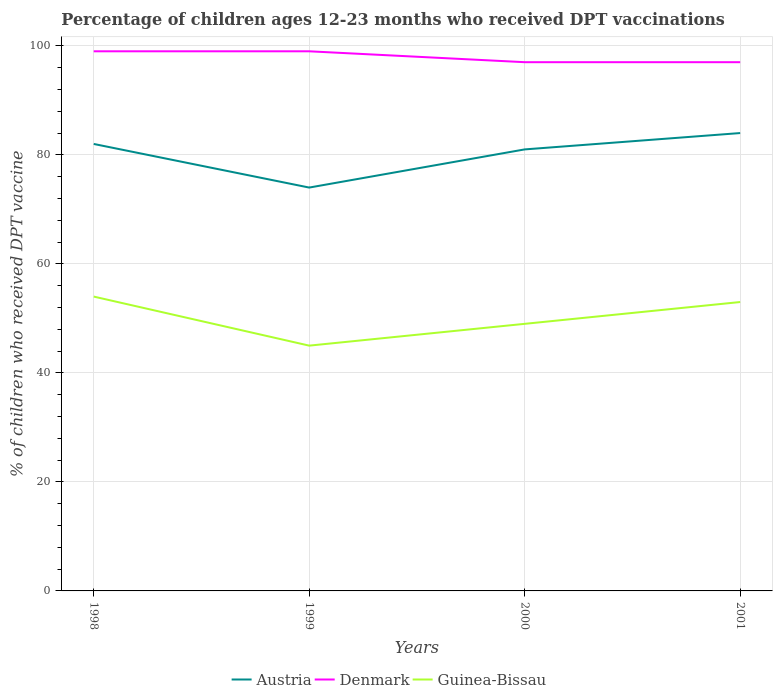Does the line corresponding to Guinea-Bissau intersect with the line corresponding to Austria?
Ensure brevity in your answer.  No. Across all years, what is the maximum percentage of children who received DPT vaccination in Austria?
Offer a very short reply. 74. In which year was the percentage of children who received DPT vaccination in Denmark maximum?
Your response must be concise. 2000. What is the difference between the highest and the second highest percentage of children who received DPT vaccination in Austria?
Provide a succinct answer. 10. What is the difference between the highest and the lowest percentage of children who received DPT vaccination in Guinea-Bissau?
Offer a very short reply. 2. Is the percentage of children who received DPT vaccination in Denmark strictly greater than the percentage of children who received DPT vaccination in Austria over the years?
Your response must be concise. No. Are the values on the major ticks of Y-axis written in scientific E-notation?
Provide a succinct answer. No. Where does the legend appear in the graph?
Offer a terse response. Bottom center. What is the title of the graph?
Keep it short and to the point. Percentage of children ages 12-23 months who received DPT vaccinations. What is the label or title of the X-axis?
Ensure brevity in your answer.  Years. What is the label or title of the Y-axis?
Your answer should be very brief. % of children who received DPT vaccine. What is the % of children who received DPT vaccine in Austria in 1998?
Your answer should be very brief. 82. What is the % of children who received DPT vaccine in Austria in 1999?
Make the answer very short. 74. What is the % of children who received DPT vaccine of Guinea-Bissau in 1999?
Offer a terse response. 45. What is the % of children who received DPT vaccine of Austria in 2000?
Your answer should be compact. 81. What is the % of children who received DPT vaccine in Denmark in 2000?
Provide a succinct answer. 97. What is the % of children who received DPT vaccine of Guinea-Bissau in 2000?
Offer a terse response. 49. What is the % of children who received DPT vaccine in Denmark in 2001?
Your answer should be very brief. 97. Across all years, what is the maximum % of children who received DPT vaccine of Austria?
Provide a succinct answer. 84. Across all years, what is the minimum % of children who received DPT vaccine of Denmark?
Offer a terse response. 97. Across all years, what is the minimum % of children who received DPT vaccine in Guinea-Bissau?
Your answer should be very brief. 45. What is the total % of children who received DPT vaccine of Austria in the graph?
Your answer should be compact. 321. What is the total % of children who received DPT vaccine of Denmark in the graph?
Your answer should be compact. 392. What is the total % of children who received DPT vaccine in Guinea-Bissau in the graph?
Your response must be concise. 201. What is the difference between the % of children who received DPT vaccine of Austria in 1998 and that in 1999?
Provide a succinct answer. 8. What is the difference between the % of children who received DPT vaccine in Austria in 1998 and that in 2000?
Offer a terse response. 1. What is the difference between the % of children who received DPT vaccine of Guinea-Bissau in 1999 and that in 2001?
Make the answer very short. -8. What is the difference between the % of children who received DPT vaccine of Austria in 2000 and that in 2001?
Provide a short and direct response. -3. What is the difference between the % of children who received DPT vaccine in Denmark in 2000 and that in 2001?
Make the answer very short. 0. What is the difference between the % of children who received DPT vaccine in Austria in 1998 and the % of children who received DPT vaccine in Guinea-Bissau in 1999?
Make the answer very short. 37. What is the difference between the % of children who received DPT vaccine in Austria in 1998 and the % of children who received DPT vaccine in Denmark in 2000?
Offer a very short reply. -15. What is the difference between the % of children who received DPT vaccine in Denmark in 1998 and the % of children who received DPT vaccine in Guinea-Bissau in 2001?
Ensure brevity in your answer.  46. What is the difference between the % of children who received DPT vaccine of Austria in 1999 and the % of children who received DPT vaccine of Denmark in 2000?
Offer a very short reply. -23. What is the difference between the % of children who received DPT vaccine of Denmark in 1999 and the % of children who received DPT vaccine of Guinea-Bissau in 2000?
Provide a short and direct response. 50. What is the difference between the % of children who received DPT vaccine in Austria in 1999 and the % of children who received DPT vaccine in Guinea-Bissau in 2001?
Offer a very short reply. 21. What is the difference between the % of children who received DPT vaccine in Denmark in 2000 and the % of children who received DPT vaccine in Guinea-Bissau in 2001?
Your answer should be compact. 44. What is the average % of children who received DPT vaccine in Austria per year?
Offer a terse response. 80.25. What is the average % of children who received DPT vaccine in Guinea-Bissau per year?
Offer a terse response. 50.25. In the year 1998, what is the difference between the % of children who received DPT vaccine of Austria and % of children who received DPT vaccine of Guinea-Bissau?
Provide a short and direct response. 28. In the year 1999, what is the difference between the % of children who received DPT vaccine of Austria and % of children who received DPT vaccine of Guinea-Bissau?
Your answer should be very brief. 29. In the year 2000, what is the difference between the % of children who received DPT vaccine in Austria and % of children who received DPT vaccine in Denmark?
Provide a short and direct response. -16. In the year 2000, what is the difference between the % of children who received DPT vaccine of Denmark and % of children who received DPT vaccine of Guinea-Bissau?
Give a very brief answer. 48. What is the ratio of the % of children who received DPT vaccine of Austria in 1998 to that in 1999?
Give a very brief answer. 1.11. What is the ratio of the % of children who received DPT vaccine in Denmark in 1998 to that in 1999?
Make the answer very short. 1. What is the ratio of the % of children who received DPT vaccine of Austria in 1998 to that in 2000?
Make the answer very short. 1.01. What is the ratio of the % of children who received DPT vaccine in Denmark in 1998 to that in 2000?
Make the answer very short. 1.02. What is the ratio of the % of children who received DPT vaccine of Guinea-Bissau in 1998 to that in 2000?
Your answer should be very brief. 1.1. What is the ratio of the % of children who received DPT vaccine of Austria in 1998 to that in 2001?
Give a very brief answer. 0.98. What is the ratio of the % of children who received DPT vaccine of Denmark in 1998 to that in 2001?
Provide a short and direct response. 1.02. What is the ratio of the % of children who received DPT vaccine in Guinea-Bissau in 1998 to that in 2001?
Offer a terse response. 1.02. What is the ratio of the % of children who received DPT vaccine in Austria in 1999 to that in 2000?
Make the answer very short. 0.91. What is the ratio of the % of children who received DPT vaccine in Denmark in 1999 to that in 2000?
Keep it short and to the point. 1.02. What is the ratio of the % of children who received DPT vaccine of Guinea-Bissau in 1999 to that in 2000?
Keep it short and to the point. 0.92. What is the ratio of the % of children who received DPT vaccine of Austria in 1999 to that in 2001?
Offer a terse response. 0.88. What is the ratio of the % of children who received DPT vaccine of Denmark in 1999 to that in 2001?
Keep it short and to the point. 1.02. What is the ratio of the % of children who received DPT vaccine in Guinea-Bissau in 1999 to that in 2001?
Your answer should be compact. 0.85. What is the ratio of the % of children who received DPT vaccine of Austria in 2000 to that in 2001?
Your response must be concise. 0.96. What is the ratio of the % of children who received DPT vaccine of Denmark in 2000 to that in 2001?
Offer a very short reply. 1. What is the ratio of the % of children who received DPT vaccine of Guinea-Bissau in 2000 to that in 2001?
Provide a succinct answer. 0.92. What is the difference between the highest and the second highest % of children who received DPT vaccine in Austria?
Make the answer very short. 2. What is the difference between the highest and the second highest % of children who received DPT vaccine in Denmark?
Provide a succinct answer. 0. What is the difference between the highest and the second highest % of children who received DPT vaccine of Guinea-Bissau?
Your answer should be very brief. 1. What is the difference between the highest and the lowest % of children who received DPT vaccine in Austria?
Provide a succinct answer. 10. What is the difference between the highest and the lowest % of children who received DPT vaccine of Denmark?
Your response must be concise. 2. What is the difference between the highest and the lowest % of children who received DPT vaccine in Guinea-Bissau?
Give a very brief answer. 9. 